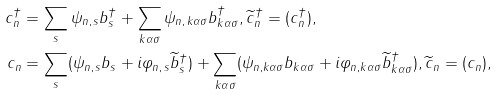<formula> <loc_0><loc_0><loc_500><loc_500>c ^ { \dag } _ { n } & = \sum _ { s } \psi _ { n , \, s } b ^ { \dagger } _ { s } + \sum _ { k \alpha \sigma } \psi _ { n , \, k \alpha \sigma } b ^ { \dag } _ { k \alpha \sigma } , \widetilde { c } ^ { \dag } _ { n } = ( c ^ { \dag } _ { n } ) , \\ c _ { n } & = \sum _ { s } ( \psi _ { n , \, s } b _ { s } + i \varphi _ { n , \, s } \widetilde { b } ^ { \dag } _ { s } ) + \sum _ { k \alpha \sigma } ( \psi _ { n , k \alpha \sigma } b _ { k \alpha \sigma } + i \varphi _ { n , k \alpha \sigma } \widetilde { b } ^ { \dag } _ { k \alpha \sigma } ) , \widetilde { c } _ { n } = ( c _ { n } ) ,</formula> 